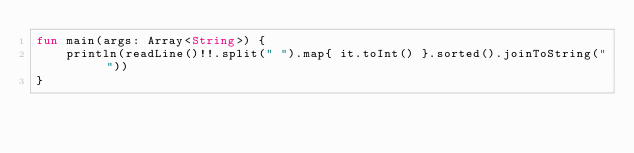<code> <loc_0><loc_0><loc_500><loc_500><_Kotlin_>fun main(args: Array<String>) {
    println(readLine()!!.split(" ").map{ it.toInt() }.sorted().joinToString(" "))
}
</code> 